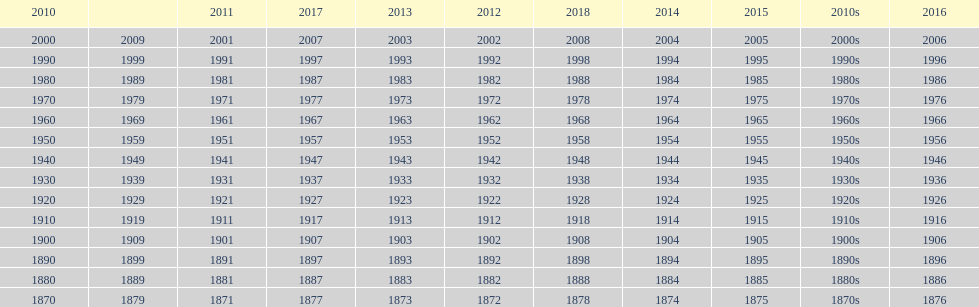What is the earliest year that a film was released? 1870. 